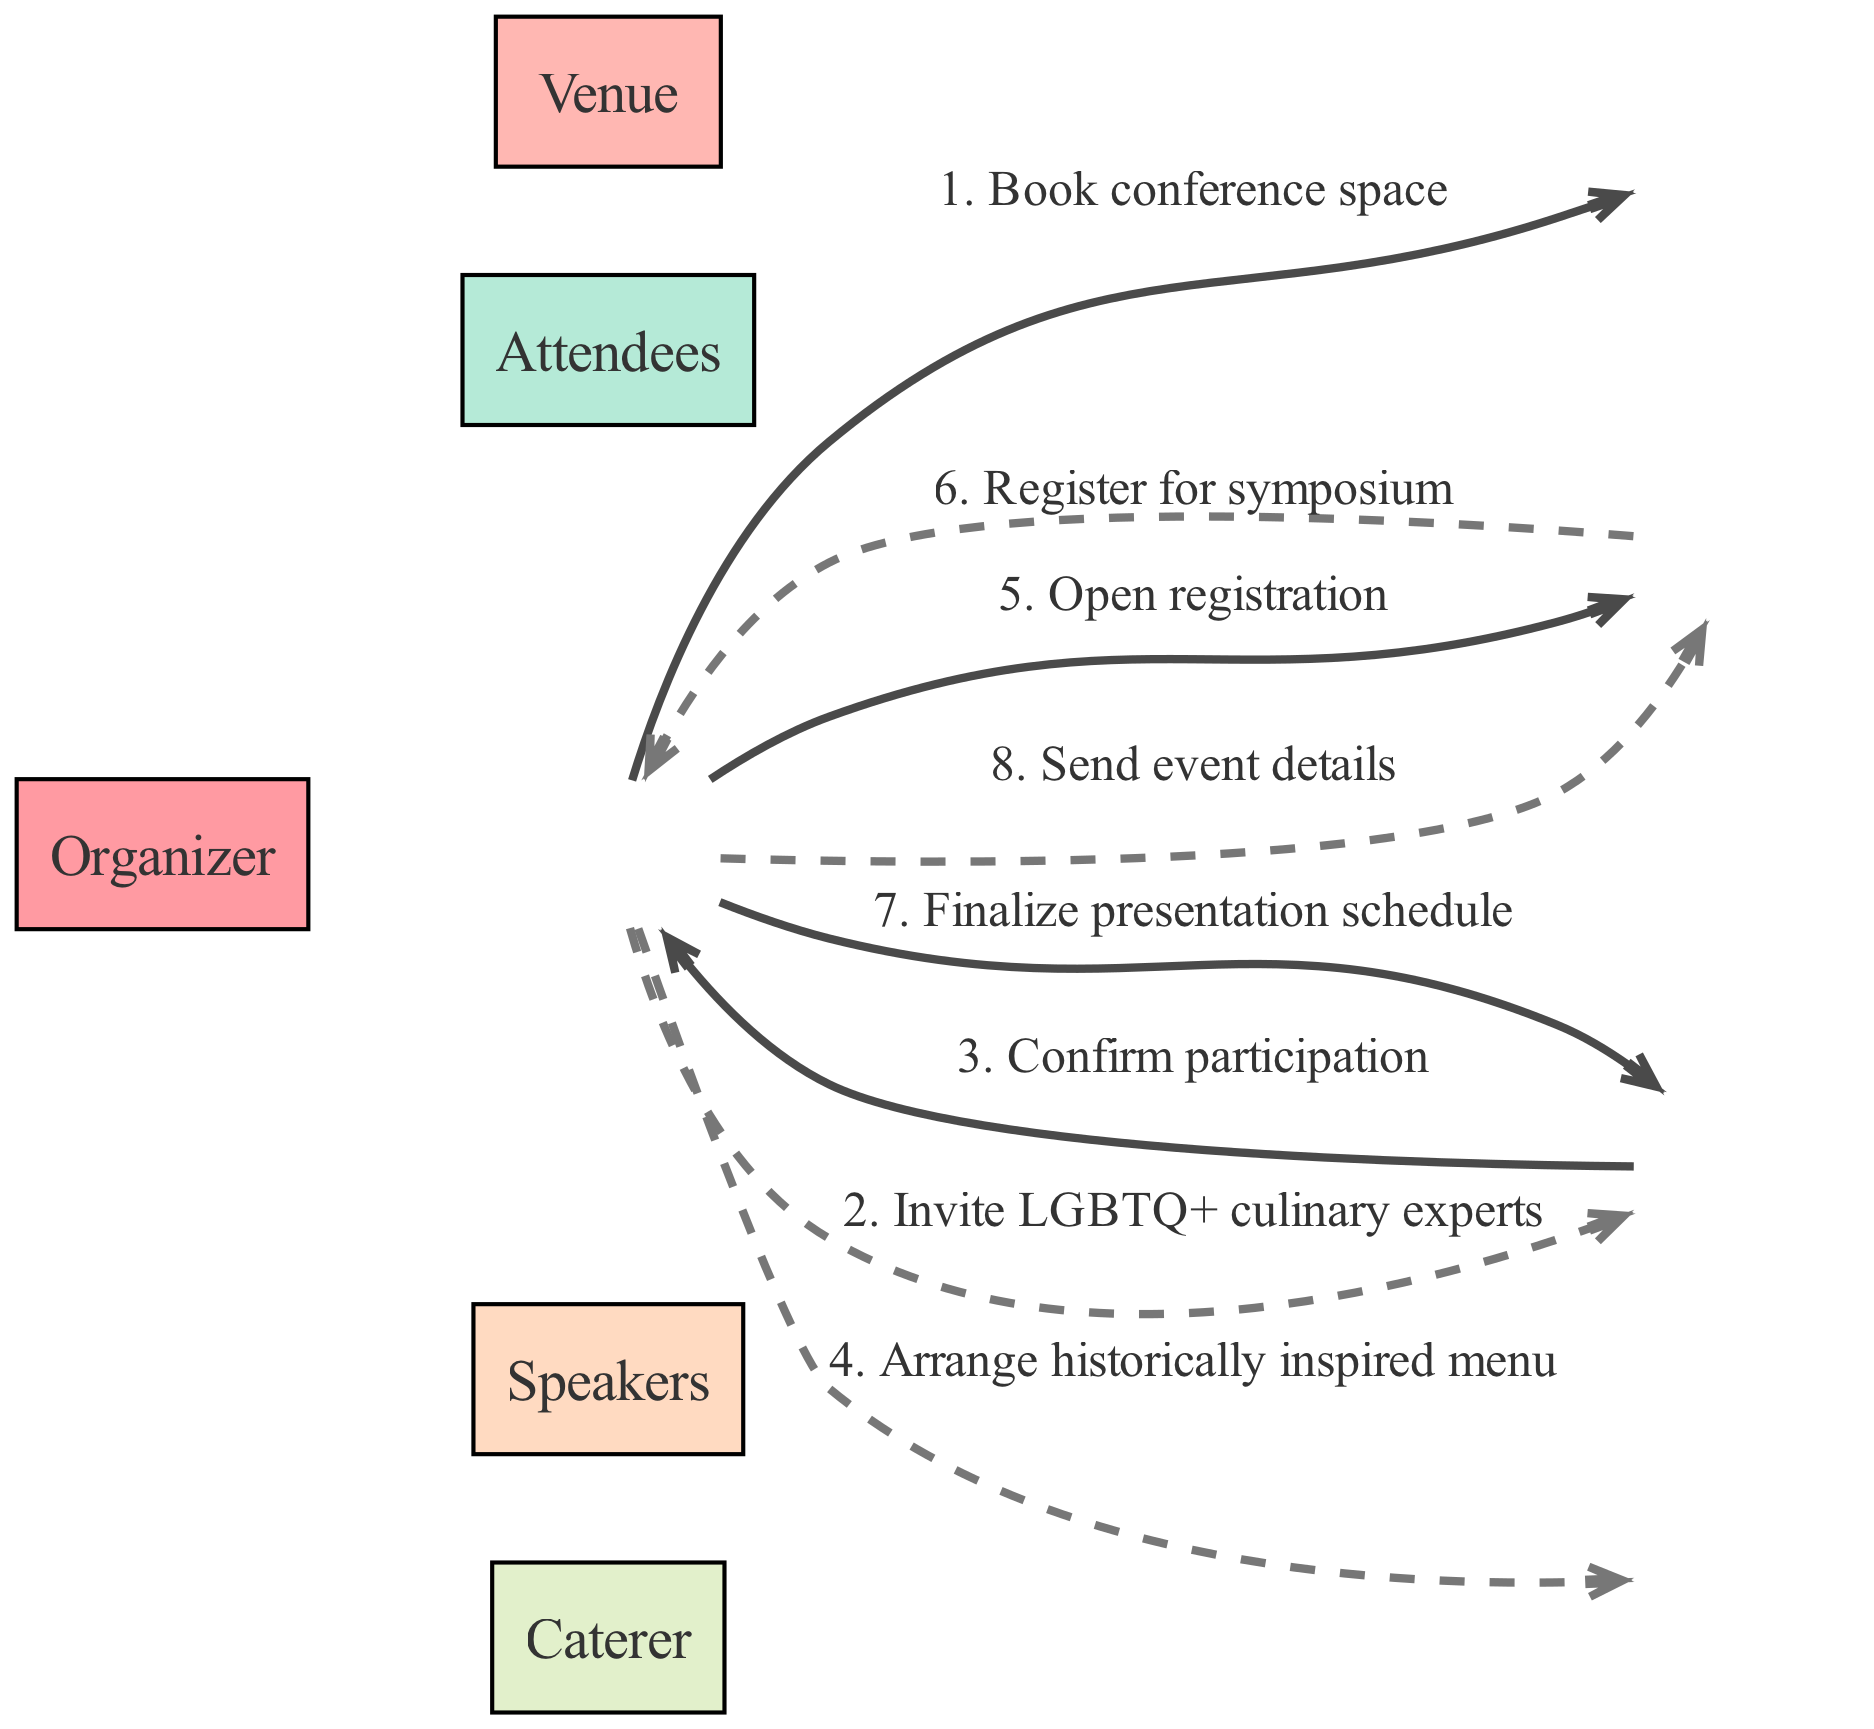What is the first action listed in the sequence? The first action in the sequence is "Book conference space," which is the first connection from the Organizer to the Venue.
Answer: Book conference space How many participants are involved in organizing the symposium? There are five participants listed in the diagram: Organizer, Venue, Speakers, Caterer, and Attendees.
Answer: Five Which participant does the Organizer send event details to? The Organizer sends event details to Attendees, as shown in the last action from Organizer to Attendees labeled "Send event details."
Answer: Attendees What action follows the confirmation of participation from Speakers? After the confirmation of participation from the Speakers, the next action is "Finalize presentation schedule" from the Organizer to the Speakers.
Answer: Finalize presentation schedule Which participant confirms their involvement in the symposium? The Speakers confirm their participation in the symposium, as indicated by the action "Confirm participation" directed back to the Organizer.
Answer: Speakers Which action directly involves the Caterer? The action that directly involves the Caterer is "Arrange historically inspired menu," which is initiated by the Organizer.
Answer: Arrange historically inspired menu How many actions are listed for the Attendees? There are two actions listed for the Attendees: "Open registration" and "Register for symposium."
Answer: Two What type of edge style is used for the second action in the sequence? The second action is represented by a dashed edge style, as indicated by the alternating edge styles throughout the diagram.
Answer: Dashed What does the Organizer initiate after sending event details? The Organizer has no further actions after sending event details, as it is the last action in the sequence.
Answer: None 